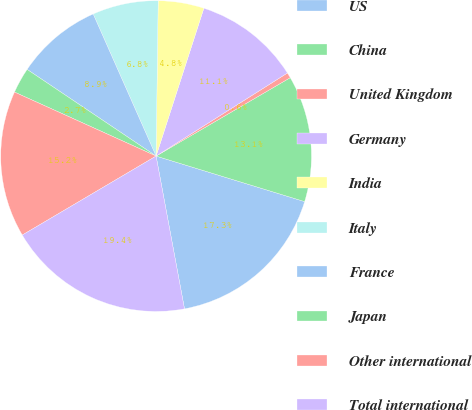Convert chart. <chart><loc_0><loc_0><loc_500><loc_500><pie_chart><fcel>US<fcel>China<fcel>United Kingdom<fcel>Germany<fcel>India<fcel>Italy<fcel>France<fcel>Japan<fcel>Other international<fcel>Total international<nl><fcel>17.34%<fcel>13.15%<fcel>0.56%<fcel>11.05%<fcel>4.76%<fcel>6.85%<fcel>8.95%<fcel>2.66%<fcel>15.24%<fcel>19.44%<nl></chart> 